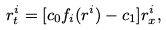Convert formula to latex. <formula><loc_0><loc_0><loc_500><loc_500>r _ { t } ^ { i } = [ c _ { 0 } f _ { i } ( r ^ { i } ) - c _ { 1 } ] r _ { x } ^ { i } ,</formula> 